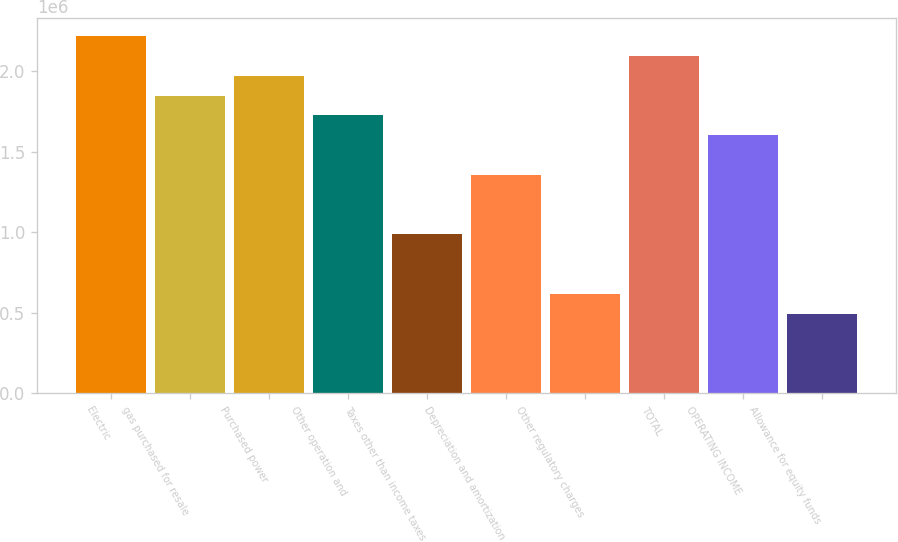<chart> <loc_0><loc_0><loc_500><loc_500><bar_chart><fcel>Electric<fcel>gas purchased for resale<fcel>Purchased power<fcel>Other operation and<fcel>Taxes other than income taxes<fcel>Depreciation and amortization<fcel>Other regulatory charges<fcel>TOTAL<fcel>OPERATING INCOME<fcel>Allowance for equity funds<nl><fcel>2.21893e+06<fcel>1.84918e+06<fcel>1.97243e+06<fcel>1.72592e+06<fcel>986421<fcel>1.35617e+06<fcel>616669<fcel>2.09568e+06<fcel>1.60267e+06<fcel>493418<nl></chart> 